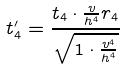Convert formula to latex. <formula><loc_0><loc_0><loc_500><loc_500>t _ { 4 } ^ { \prime } = \frac { t _ { 4 } \cdot \frac { v } { h ^ { 4 } } r _ { 4 } } { \sqrt { 1 \cdot \frac { v ^ { 4 } } { h ^ { 4 } } } }</formula> 